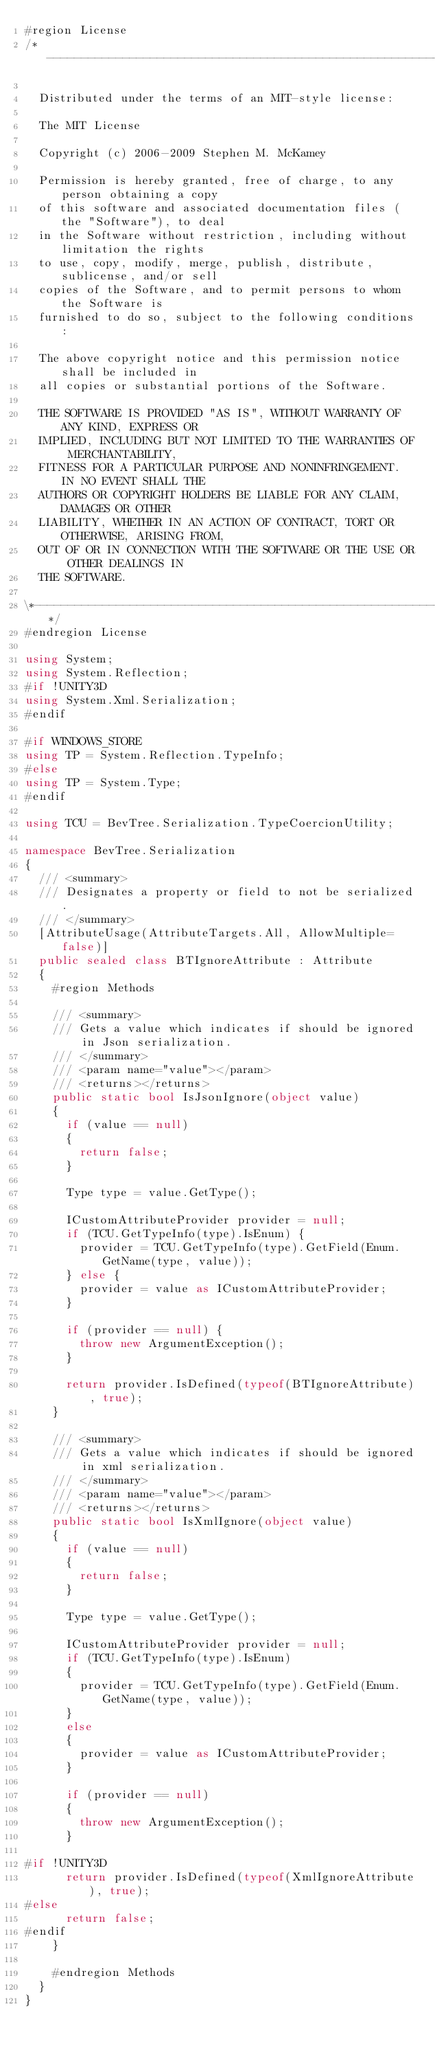<code> <loc_0><loc_0><loc_500><loc_500><_C#_>#region License
/*---------------------------------------------------------------------------------*\

	Distributed under the terms of an MIT-style license:

	The MIT License

	Copyright (c) 2006-2009 Stephen M. McKamey

	Permission is hereby granted, free of charge, to any person obtaining a copy
	of this software and associated documentation files (the "Software"), to deal
	in the Software without restriction, including without limitation the rights
	to use, copy, modify, merge, publish, distribute, sublicense, and/or sell
	copies of the Software, and to permit persons to whom the Software is
	furnished to do so, subject to the following conditions:

	The above copyright notice and this permission notice shall be included in
	all copies or substantial portions of the Software.

	THE SOFTWARE IS PROVIDED "AS IS", WITHOUT WARRANTY OF ANY KIND, EXPRESS OR
	IMPLIED, INCLUDING BUT NOT LIMITED TO THE WARRANTIES OF MERCHANTABILITY,
	FITNESS FOR A PARTICULAR PURPOSE AND NONINFRINGEMENT. IN NO EVENT SHALL THE
	AUTHORS OR COPYRIGHT HOLDERS BE LIABLE FOR ANY CLAIM, DAMAGES OR OTHER
	LIABILITY, WHETHER IN AN ACTION OF CONTRACT, TORT OR OTHERWISE, ARISING FROM,
	OUT OF OR IN CONNECTION WITH THE SOFTWARE OR THE USE OR OTHER DEALINGS IN
	THE SOFTWARE.

\*---------------------------------------------------------------------------------*/
#endregion License

using System;
using System.Reflection;
#if !UNITY3D
using System.Xml.Serialization;
#endif

#if WINDOWS_STORE
using TP = System.Reflection.TypeInfo;
#else
using TP = System.Type;
#endif

using TCU = BevTree.Serialization.TypeCoercionUtility;

namespace BevTree.Serialization
{
	/// <summary>
	/// Designates a property or field to not be serialized.
	/// </summary>
	[AttributeUsage(AttributeTargets.All, AllowMultiple=false)]
	public sealed class BTIgnoreAttribute : Attribute
	{
		#region Methods

		/// <summary>
		/// Gets a value which indicates if should be ignored in Json serialization.
		/// </summary>
		/// <param name="value"></param>
		/// <returns></returns>
		public static bool IsJsonIgnore(object value)
		{
			if (value == null)
			{
				return false;
			}

			Type type = value.GetType();

			ICustomAttributeProvider provider = null;
			if (TCU.GetTypeInfo(type).IsEnum) {
				provider = TCU.GetTypeInfo(type).GetField(Enum.GetName(type, value));
			} else {
				provider = value as ICustomAttributeProvider;
			}

			if (provider == null) {
				throw new ArgumentException();
			}

			return provider.IsDefined(typeof(BTIgnoreAttribute), true);
		}

		/// <summary>
		/// Gets a value which indicates if should be ignored in xml serialization.
		/// </summary>
		/// <param name="value"></param>
		/// <returns></returns>
		public static bool IsXmlIgnore(object value)
		{
			if (value == null)
			{
				return false;
			}

			Type type = value.GetType();

			ICustomAttributeProvider provider = null;
			if (TCU.GetTypeInfo(type).IsEnum)
			{
				provider = TCU.GetTypeInfo(type).GetField(Enum.GetName(type, value));
			}
			else
			{
				provider = value as ICustomAttributeProvider;
			}

			if (provider == null)
			{
				throw new ArgumentException();
			}

#if !UNITY3D
			return provider.IsDefined(typeof(XmlIgnoreAttribute), true);
#else
			return false;
#endif
		}

		#endregion Methods
	}
}
</code> 